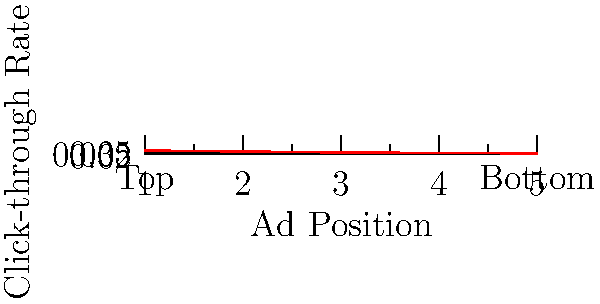Based on the line graph showing click-through rates for different ad placement positions, what would be the most likely click-through rate for an ad placed in position 6, assuming the trend continues? To predict the click-through rate for position 6, we need to analyze the trend in the given data:

1. Observe the pattern: As the ad position moves from top to bottom (1 to 5), the click-through rate decreases.

2. Calculate the rate of change:
   - From position 1 to 2: 0.05 - 0.04 = 0.01 decrease
   - From position 2 to 3: 0.04 - 0.03 = 0.01 decrease
   - From position 3 to 4: 0.03 - 0.025 = 0.005 decrease
   - From position 4 to 5: 0.025 - 0.02 = 0.005 decrease

3. Notice that the rate of decrease is slowing down:
   - It starts at 0.01 per position
   - Then reduces to 0.005 per position

4. Predict for position 6:
   - The last observed decrease was 0.005
   - Assuming this trend continues, we expect a decrease of about 0.005 or slightly less

5. Calculate the predicted click-through rate:
   Position 5 rate: 0.02
   Expected decrease: ≈ 0.005
   Predicted rate for position 6: 0.02 - 0.005 = 0.015

Therefore, the most likely click-through rate for an ad in position 6 would be approximately 0.015 or 1.5%.
Answer: Approximately 0.015 (1.5%) 